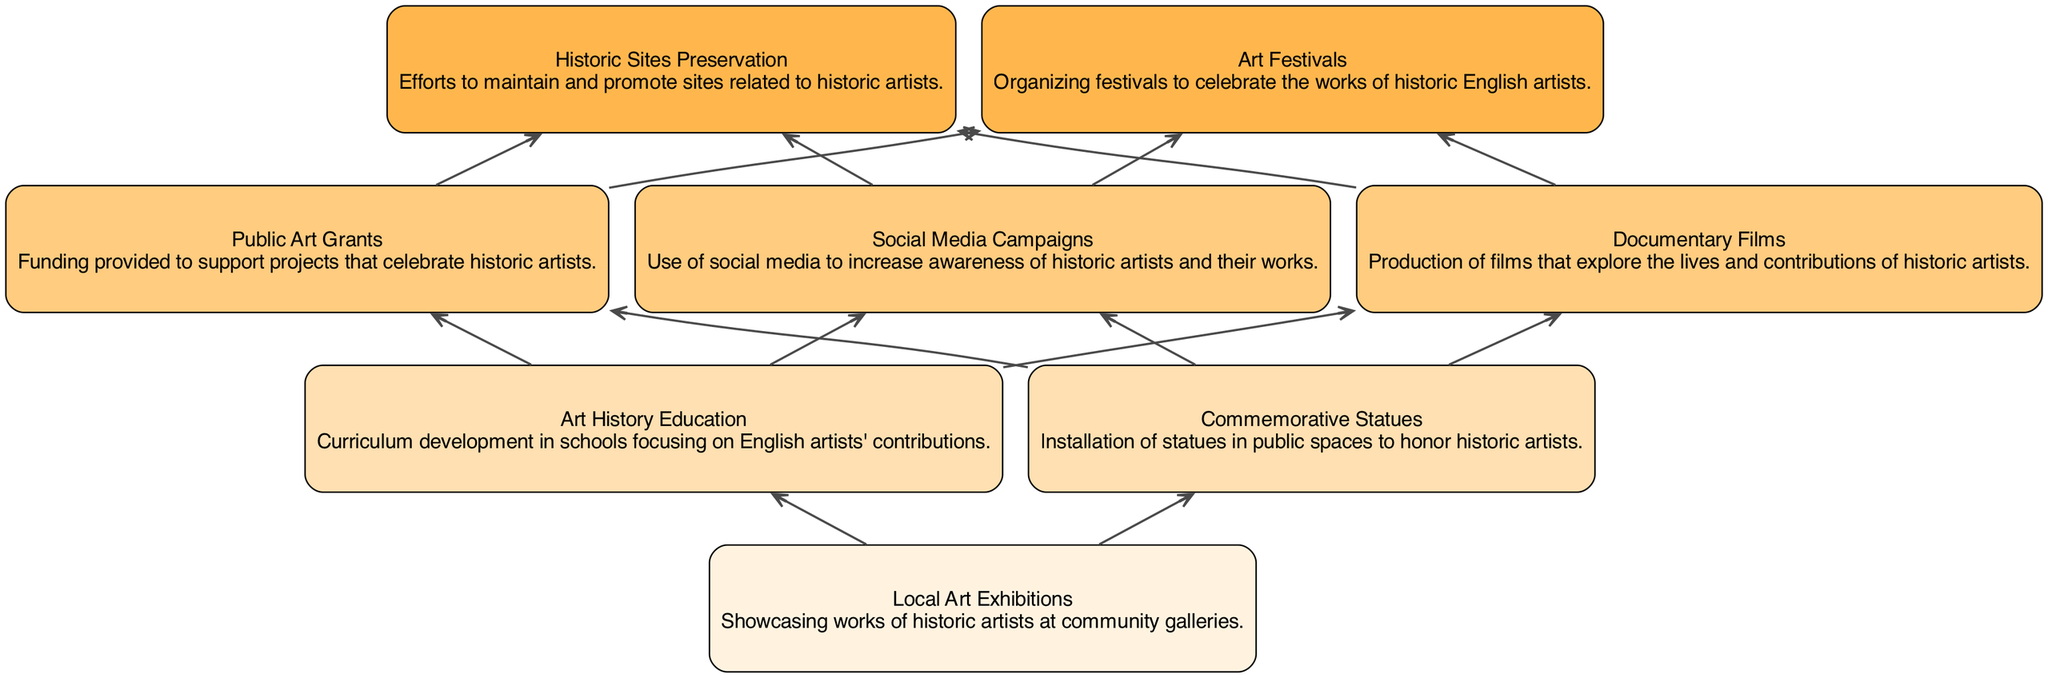What is the highest level in the diagram? The highest level can be identified by looking for the nodes with the greatest level number. Reviewing the levels in the elements, the highest is level 4 with nodes such as 'Historic Sites Preservation' and 'Art Festivals'.
Answer: 4 How many nodes are there in total? To count the total number of nodes, one can simply tally all the elements listed in the diagram. There are 8 distinct elements indicating the nodes included.
Answer: 8 Which element is specifically about social media? The element related to social media can be found by searching through the descriptions of the nodes. 'Social Media Campaigns' explicitly addresses increasing awareness through social media.
Answer: Social Media Campaigns What connects 'Local Art Exhibitions' to 'Art History Education'? To identify the connection, observe the flow of the diagram that shows arrows from one node to another. 'Local Art Exhibitions' is the first node and connects directly up to 'Art History Education', which is the next level.
Answer: Art History Education Which elements have level 2? To find the elements at level 2, review the elements and their respective levels. The nodes for level 2 include 'Art History Education' and 'Commemorative Statues'.
Answer: Art History Education, Commemorative Statues Which element is about funding support for historic artists? The funding support can be identified by examining the descriptions linked to funding initiatives. 'Public Art Grants' specifically notes financing for projects that celebrate historic artists' contributions.
Answer: Public Art Grants How many edges connect level 3 to level 4? To count the edges between level 3 and level 4, check the connections in the diagram. There are connections from all three level 3 nodes (Public Art Grants, Social Media Campaigns, Documentary Films) to the two nodes at level 4 (Historic Sites Preservation, Art Festivals), resulting in three edges in total.
Answer: 3 What type of events do ‘Art Festivals’ celebrate? The description for 'Art Festivals' specifies that they celebrate the works of historic English artists. This directly indicates the type of events associated with the node.
Answer: Works of historic English artists 